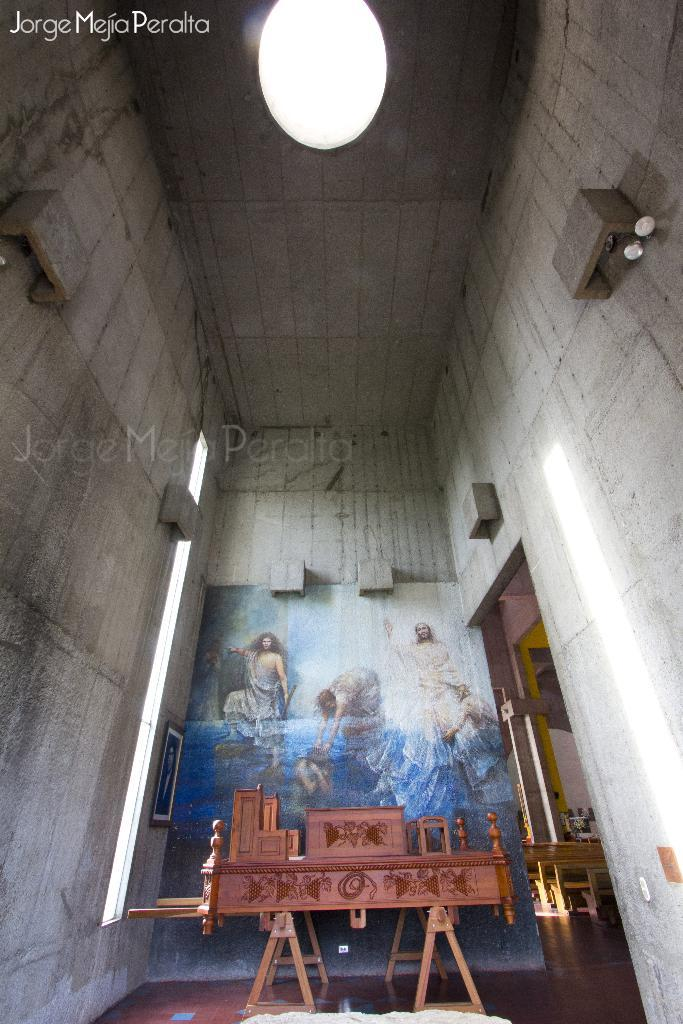What type of location is depicted in the image? The image is an inside view of a building. What furniture can be seen in the image? There is a wooden table in the back of the image. Are there any decorations on the walls in the image? Yes, there is a painting on the wall in the image. Can you describe any imperfections in the image? There is a water mark on the image. How much corn is present on the table in the image? There is no corn present on the table in the image. Is there any jam visible in the image? There is no jam visible in the image. 